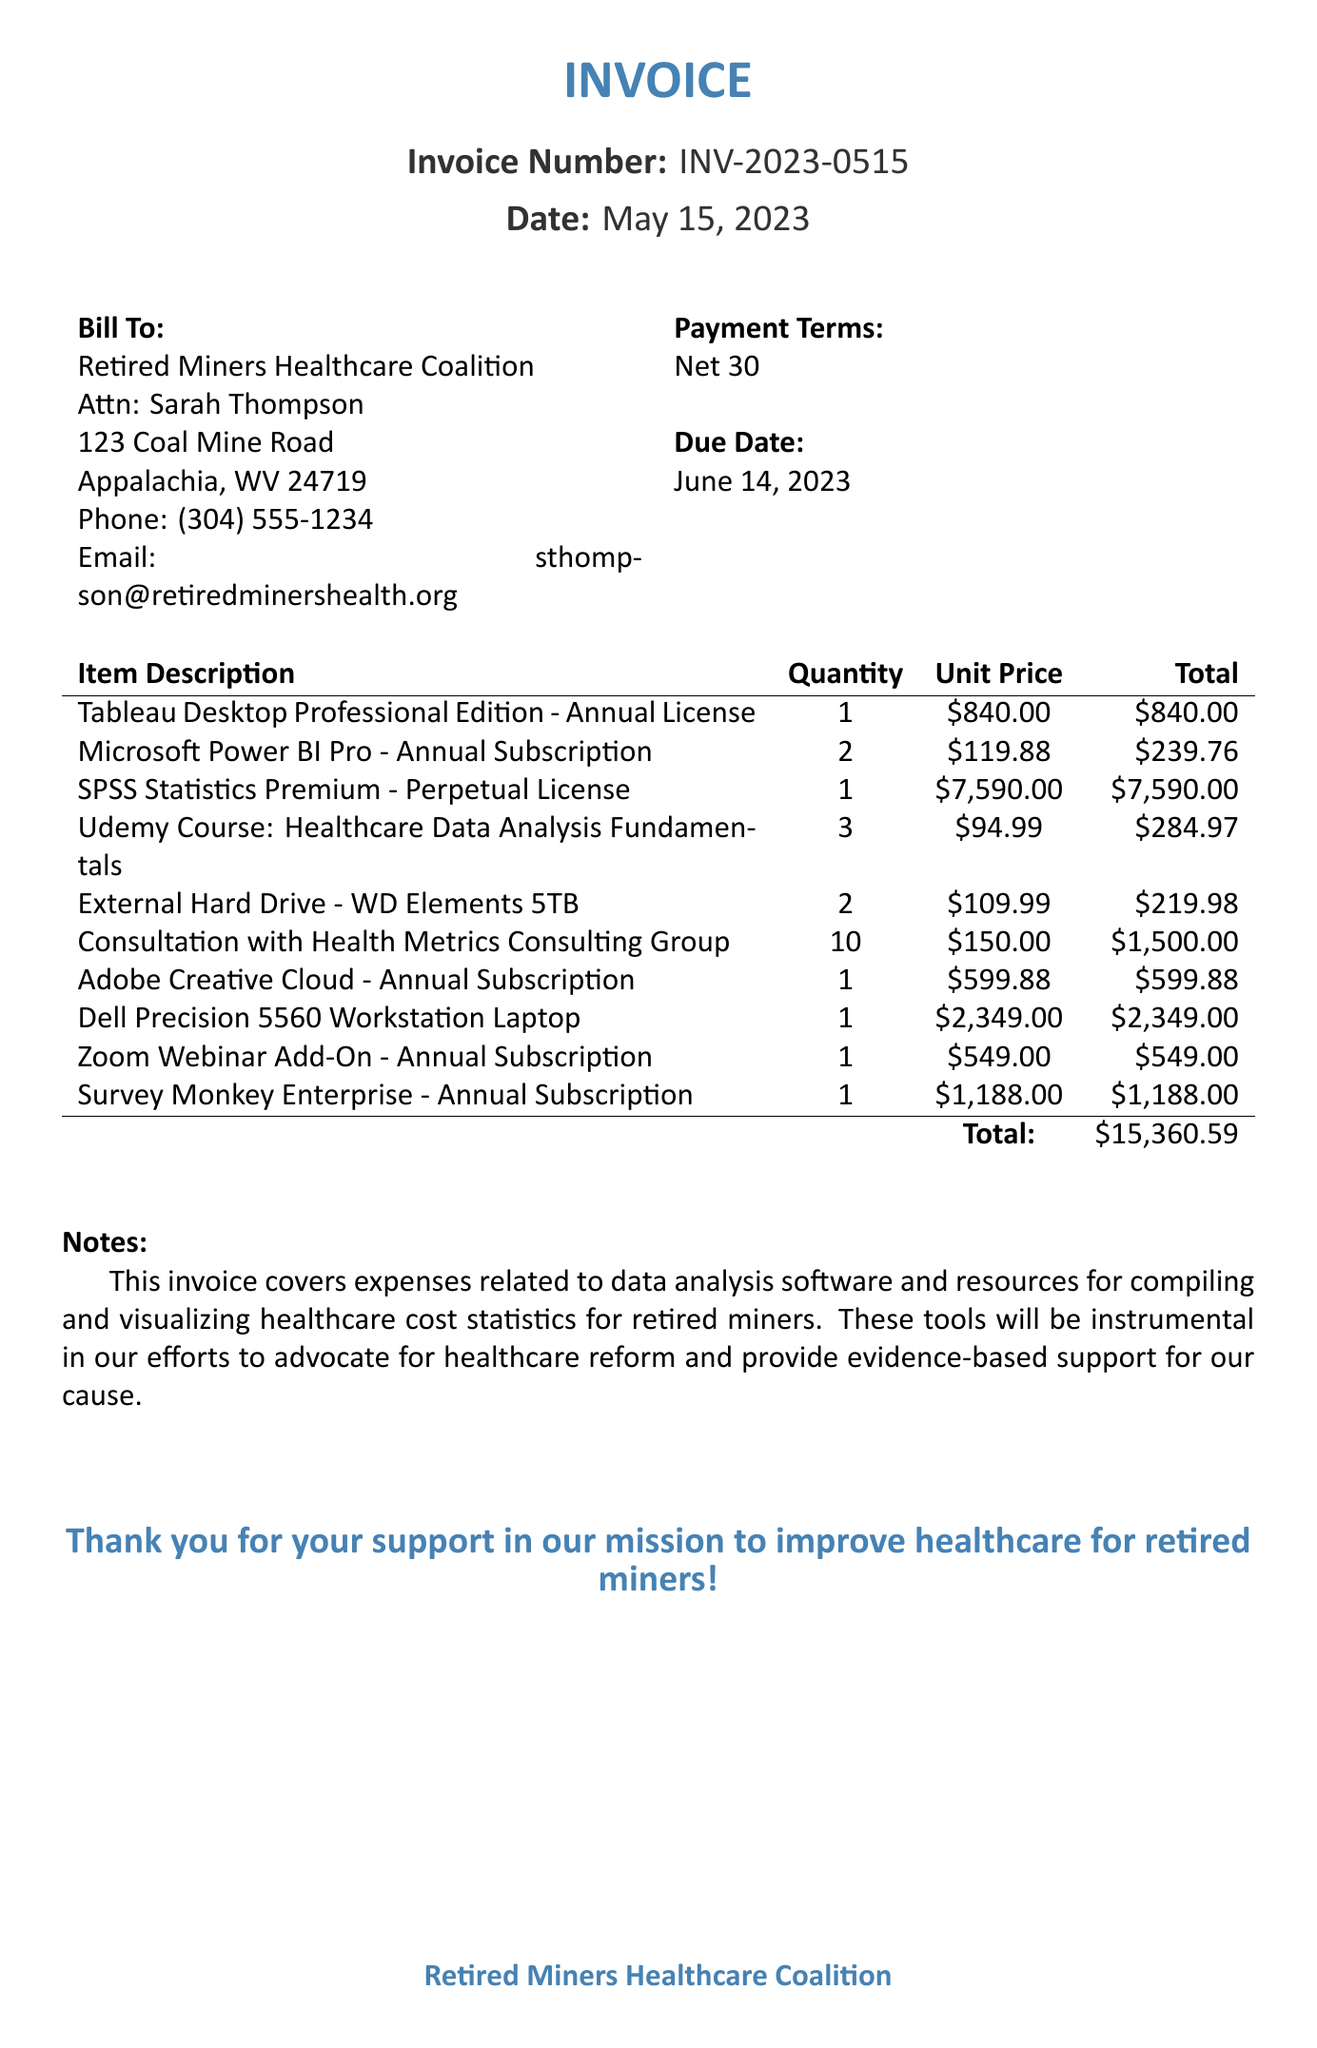What is the invoice number? The invoice number can be found under the invoice heading, showing the unique identification for this document.
Answer: INV-2023-0515 Who is the contact person for billing? This information is provided in the billing section, indicating the person responsible for inquiries about the invoice.
Answer: Sarah Thompson What is the total amount due on the invoice? The total is calculated by summing all item totals listed in the document, found at the bottom of the invoice items table.
Answer: $15,360.59 How many consultations were scheduled with the Health Metrics Consulting Group? The number of consultations can be seen in the invoice item description where it specifies quantity.
Answer: 10 What is the due date for this invoice? The due date is indicated in the payment terms section, representing when the payment is expected.
Answer: June 14, 2023 What software is listed as a perpetual license? This information can be found under the item descriptions, indicating the type of license for that specific software.
Answer: SPSS Statistics Premium How many Udemy courses were purchased? The quantity of Udemy courses can be found in the invoice items table, specifically listed under the item description.
Answer: 3 What is the purpose of the items listed in this invoice? The purpose can be inferred from the notes section, which describes the overall aim of these purchases.
Answer: Data analysis for healthcare cost statistics What type of subscription is the Microsoft Power BI Pro? This information can be found in the details of the invoice item, revealing the subscription nature of the software.
Answer: Annual Subscription 